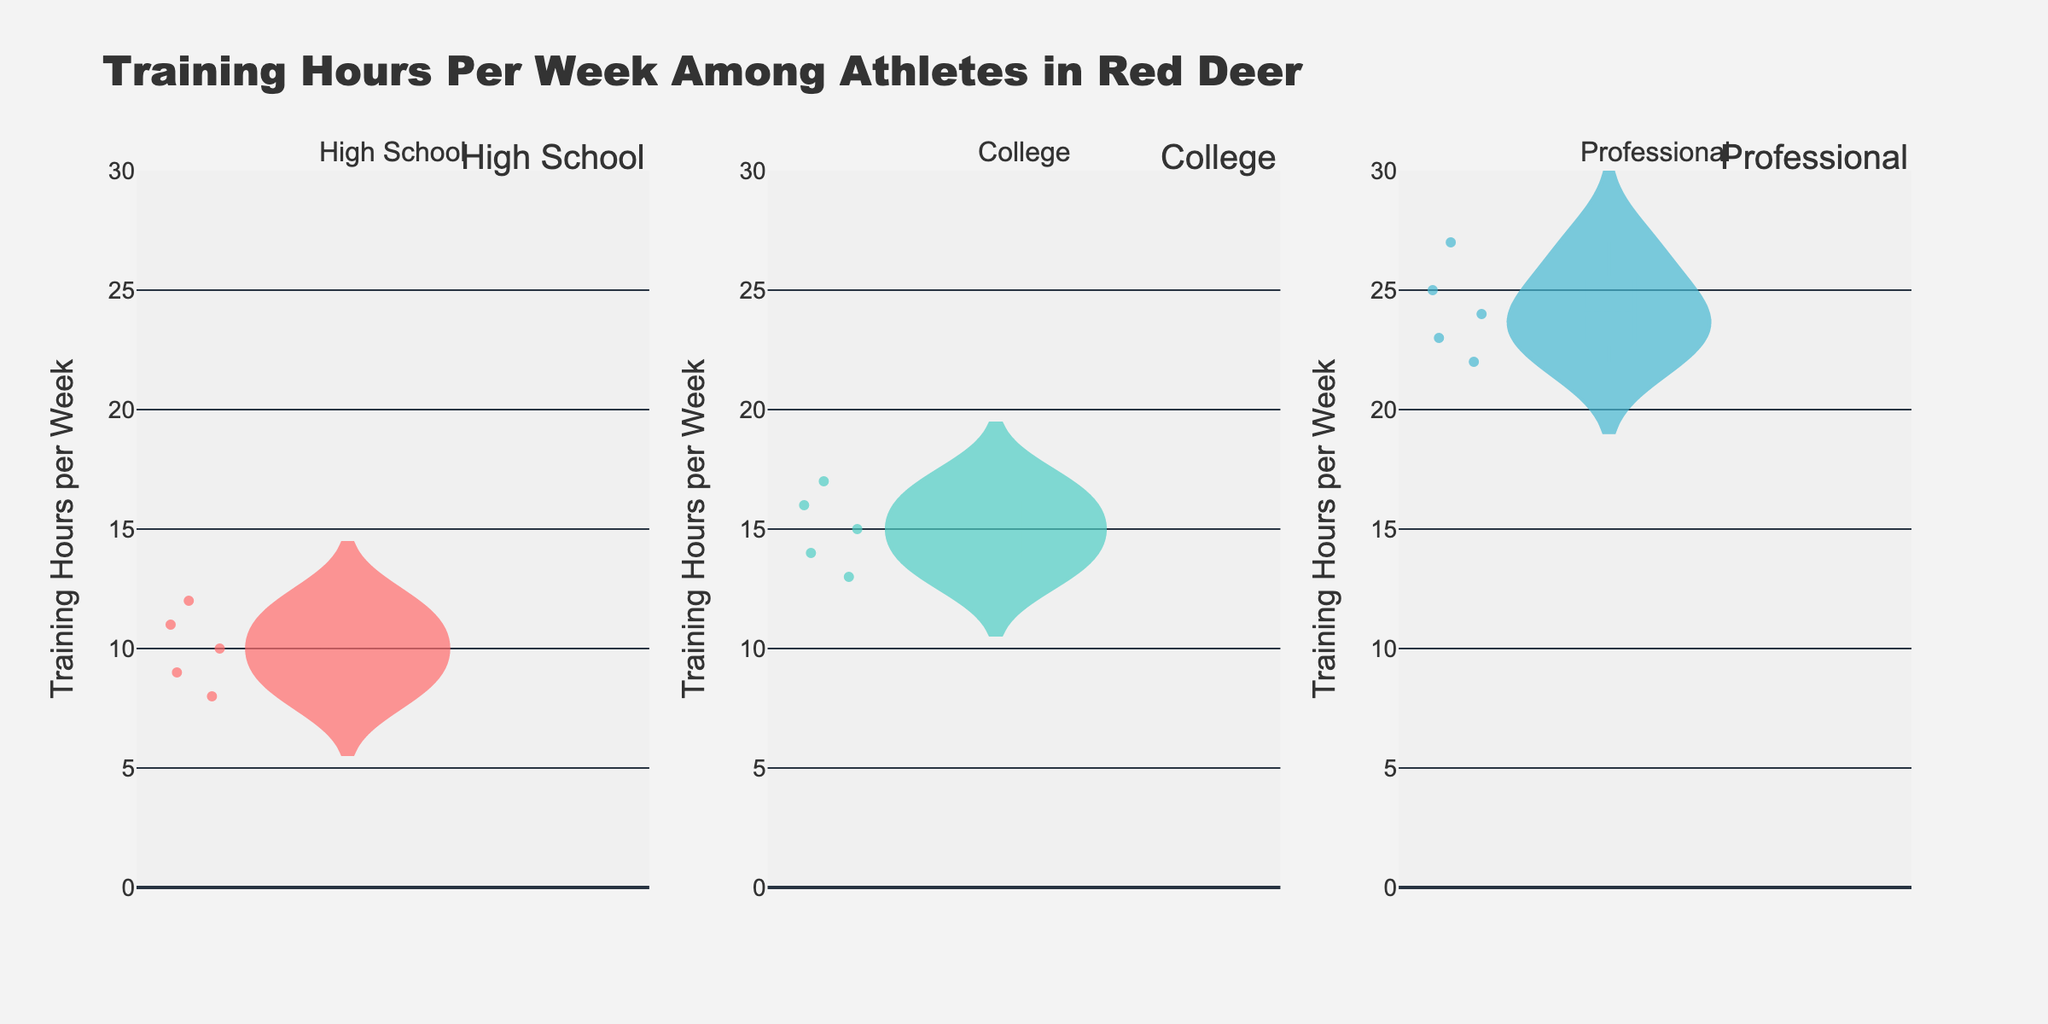How many categories are shown in the plot? The plot displays subplots for three categories as indicated by the subplot titles and annotations at the top of each subplot: High School, College, and Professional.
Answer: 3 What is the range of training hours per week for professional athletes? The range can be determined by looking at the minimum and maximum points in the “Professional” violin plot. The plot shows the minimum is around 22 hours, and the maximum is around 27 hours.
Answer: 22-27 hours Which category has the highest median training hours per week? The median is visually represented by a horizontal line within the violin plot. Among the High School, College, and Professional categories, the median line is highest in the Professional category.
Answer: Professional What is the interquartile range (IQR) for the College athletes' training hours per week? To determine the IQR, examine the range where the bulk of the data points are concentrated in the College violin plot. This range is typically between the 25th percentile and the 75th percentile. The box within the violin helps estimate this range. The 25th percentile appears to be around 14 hours, and the 75th percentile around 16 hours, giving an IQR of 2 hours.
Answer: 2 hours Compare the number of training hours between the High School and College athletes. Which group generally trains more? Observing the relative lengths and positions of the violin plots' main bodies (distributions), we can see that College athletes’ training hours are generally higher than High School athletes as their range is focused on higher hours.
Answer: College What is the maximum training hours per week recorded in the College athletes category? The maximum value is shown towards the upper region of the College violin plot, which visually peaks around the 17-hour mark.
Answer: 17 hours Are there any outliers in the High School athletes' training hours, and if so, what are they? Outliers are represented by individual points outside the main body of the violin plot. The High School plot does not show significant isolated points indicating outliers, so there are no obvious outliers.
Answer: No Which category shows the largest variability in training hours per week? Variability can be assessed by the spread of the violin plot. The Professional category has a larger range (22 to 27 hours) compared to High School and College categories, indicating higher variability.
Answer: Professional How does the average training hours of College athletes compare to Professional athletes? The mean is indicated by a line through the middle of the box in the violin plot. The College average line is lower than the corresponding line for the Professional category, indicating College athletes train fewer hours on average compared to Professional athletes.
Answer: Professional athletes train more What does the width of the violins in each category represent? The width of the violin at different values indicates the density of the data points at those values. A wider section means more data points at that training hour value. This helps in understanding the distribution within each category.
Answer: Density of data points 